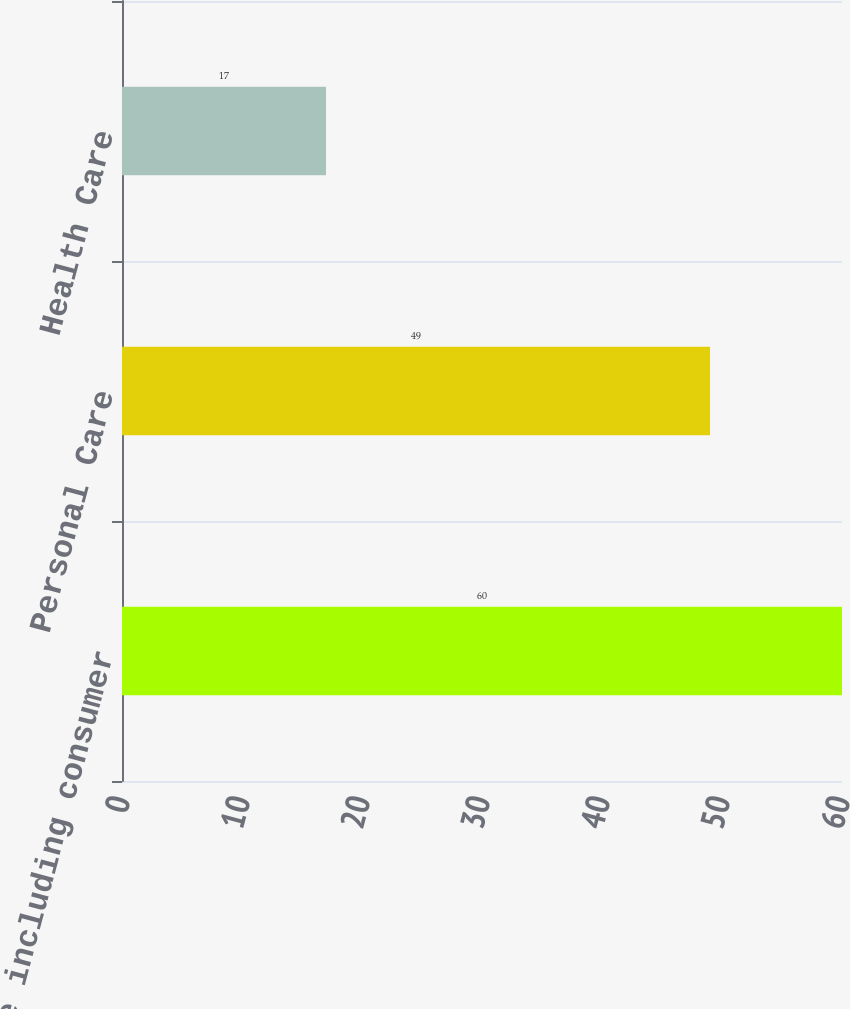Convert chart. <chart><loc_0><loc_0><loc_500><loc_500><bar_chart><fcel>Tissue including consumer<fcel>Personal Care<fcel>Health Care<nl><fcel>60<fcel>49<fcel>17<nl></chart> 